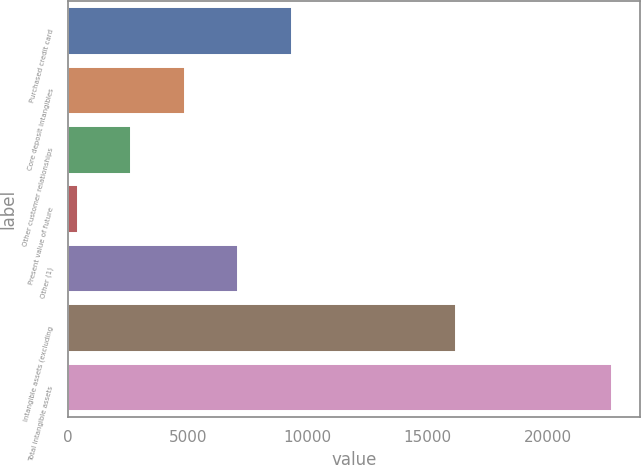<chart> <loc_0><loc_0><loc_500><loc_500><bar_chart><fcel>Purchased credit card<fcel>Core deposit intangibles<fcel>Other customer relationships<fcel>Present value of future<fcel>Other (1)<fcel>Intangible assets (excluding<fcel>Total intangible assets<nl><fcel>9326.8<fcel>4872.4<fcel>2645.2<fcel>418<fcel>7099.6<fcel>16160<fcel>22690<nl></chart> 